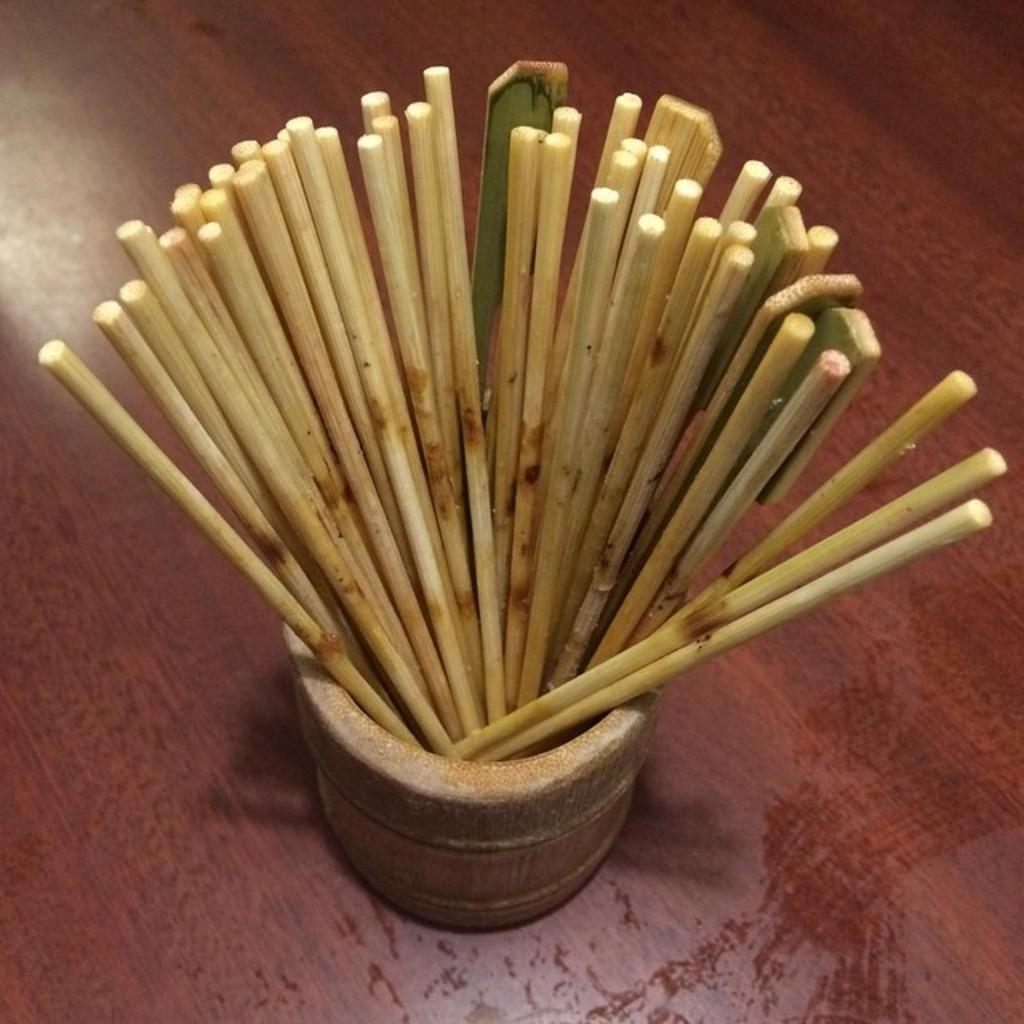What type of objects are in the image? There is a group of wooden sticks in the image. How are the wooden sticks arranged or organized? The wooden sticks are in a container. Where is the container with the wooden sticks located? The container is on a table. What type of seed can be seen growing on the wooden sticks in the image? There is no seed or plant growth visible on the wooden sticks in the image. 